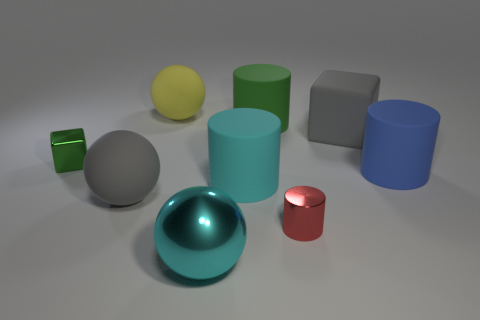What number of spheres are made of the same material as the large cube?
Provide a short and direct response. 2. How many things are big green things or gray matte blocks?
Your answer should be very brief. 2. Are any big cyan rubber objects visible?
Provide a succinct answer. Yes. There is a thing that is to the left of the large gray sphere left of the big yellow rubber object that is behind the blue thing; what is its material?
Provide a succinct answer. Metal. Is the number of metallic things that are in front of the blue cylinder less than the number of large blue cylinders?
Offer a very short reply. No. There is another object that is the same size as the red thing; what is it made of?
Offer a very short reply. Metal. There is a matte thing that is behind the small green shiny thing and right of the big green cylinder; what is its size?
Offer a terse response. Large. There is a red metal thing that is the same shape as the cyan matte thing; what is its size?
Ensure brevity in your answer.  Small. What number of objects are either gray blocks or blue rubber cylinders to the right of the tiny block?
Give a very brief answer. 2. The large yellow rubber object has what shape?
Your response must be concise. Sphere. 